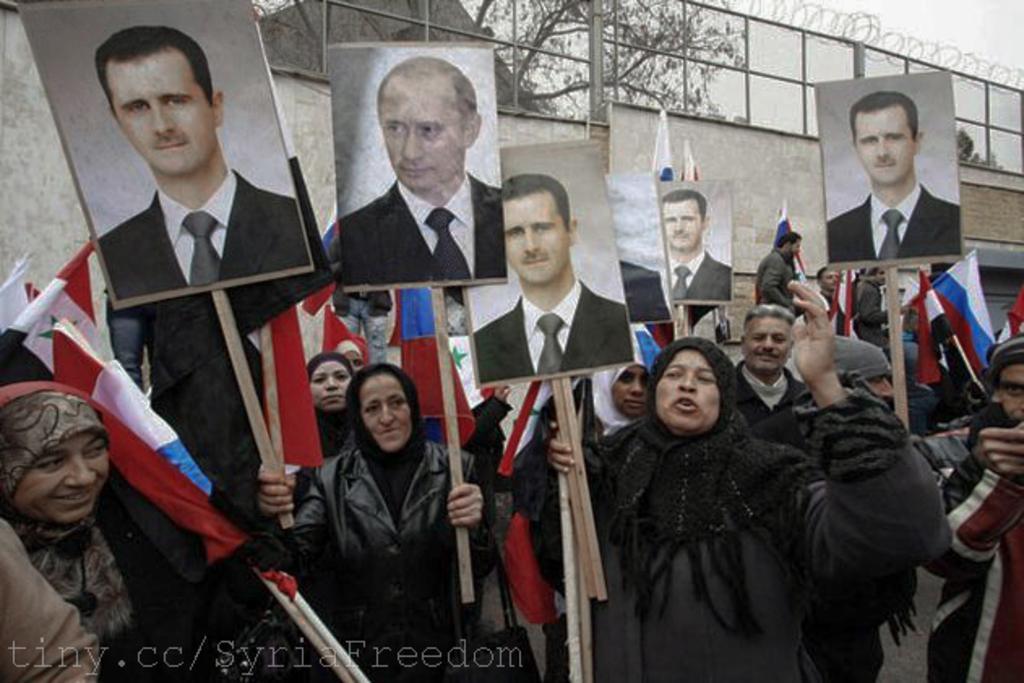Describe this image in one or two sentences. In the image we can see there are people wearing clothes and some of them are wearing a cap. They are holding a pole with the poster in their hands. In the poster we can see there is a picture of a person wearing clothes. Here we can see the flags, wall, fence, trees and the sky. On the bottom left we can see watermark. 